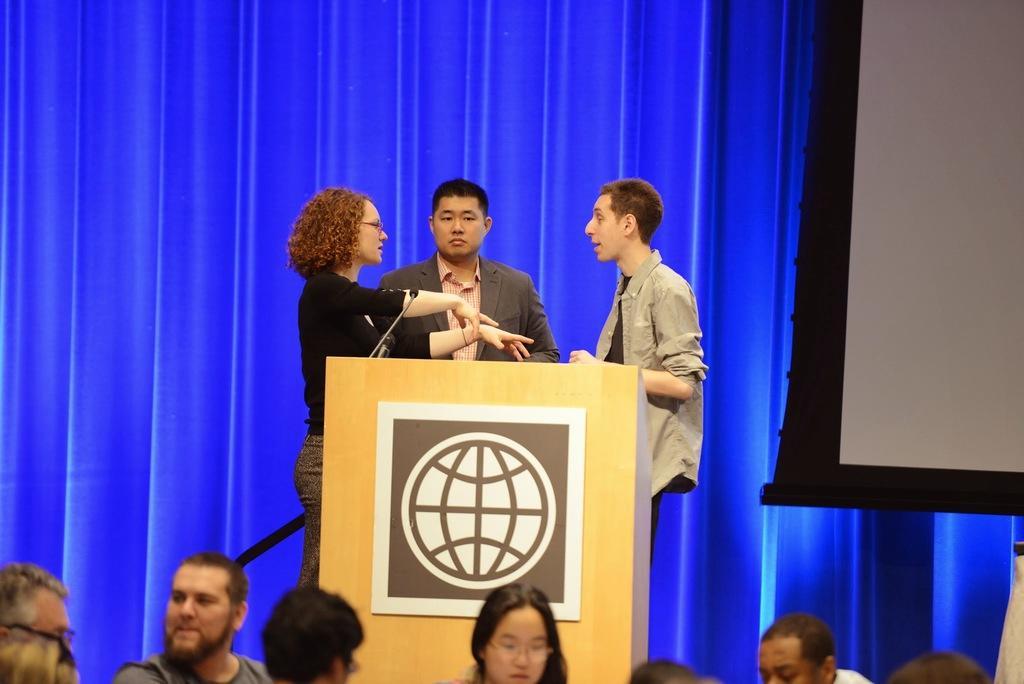Please provide a concise description of this image. In the picture I can see three persons standing in front of the wooden podium. I can see a few people at the bottom of the image. There is a woman on the left side wearing the black color top and she is speaking. I can see a man in the middle wearing a suit. In the background, I can see the blue color curtain. It is looking like a screen on the right side. 